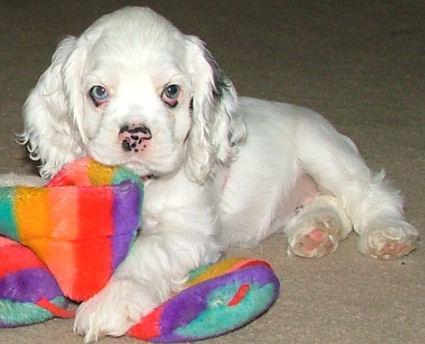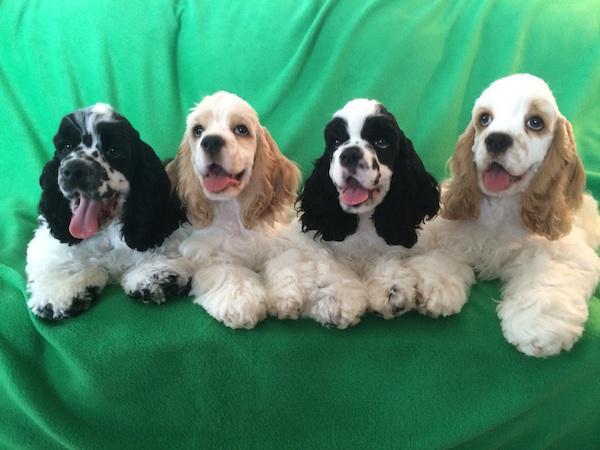The first image is the image on the left, the second image is the image on the right. Given the left and right images, does the statement "Right image shows one dog on green grass, and the dog has white fur on its face with darker fur on its earsand around its eyes." hold true? Answer yes or no. No. The first image is the image on the left, the second image is the image on the right. Considering the images on both sides, is "The dogs in both images are sitting on the grass." valid? Answer yes or no. No. 